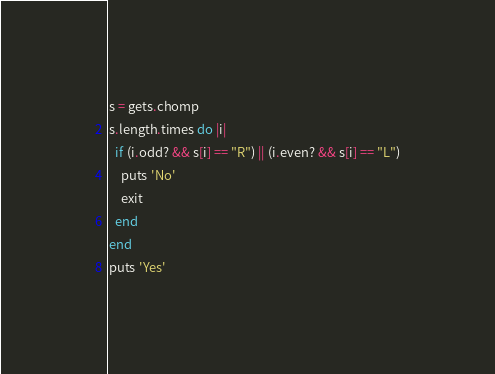<code> <loc_0><loc_0><loc_500><loc_500><_Ruby_>s = gets.chomp
s.length.times do |i|
  if (i.odd? && s[i] == "R") || (i.even? && s[i] == "L")
    puts 'No'
    exit
  end
end
puts 'Yes'
</code> 